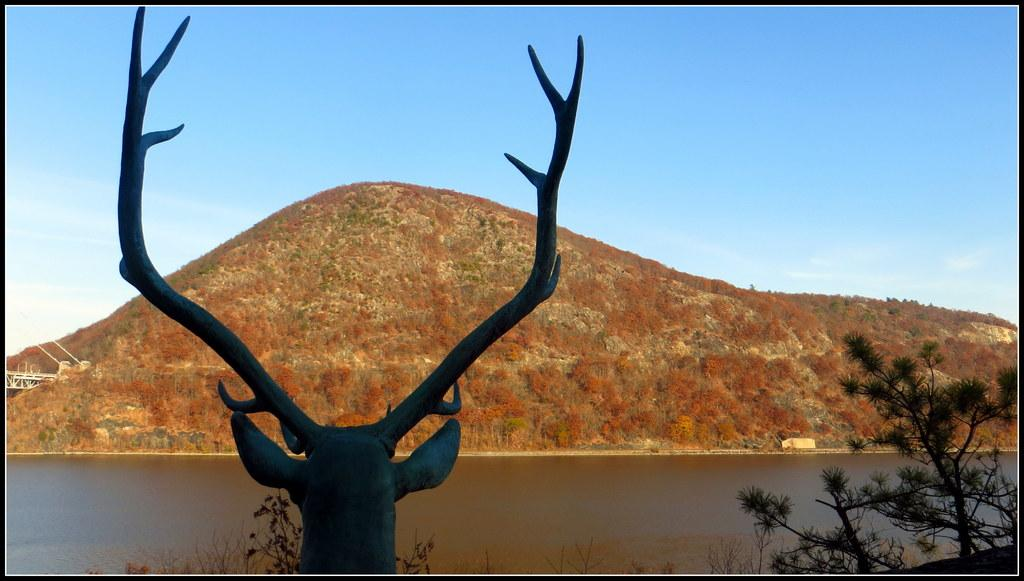What type of animal head is depicted in the image? There is an animal head with horns in the image. What can be seen in the foreground of the image? Water and branches of trees are visible in the image. What is the landscape feature in the background of the image? There is a hill in the background of the image. What is visible above the landscape in the image? The sky is visible in the image, and clouds are present in the sky. What type of stew is being prepared in the image? There is no indication of any stew being prepared in the image; it primarily features an animal head with horns and a landscape. 